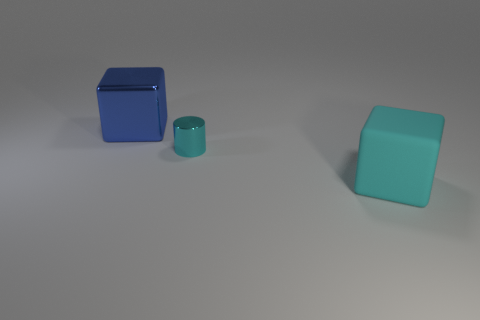Subtract all purple cylinders. Subtract all purple balls. How many cylinders are left? 1 Add 1 cyan cubes. How many objects exist? 4 Subtract all cubes. How many objects are left? 1 Subtract all tiny yellow shiny things. Subtract all cyan objects. How many objects are left? 1 Add 1 shiny objects. How many shiny objects are left? 3 Add 2 cyan metal things. How many cyan metal things exist? 3 Subtract 0 red balls. How many objects are left? 3 